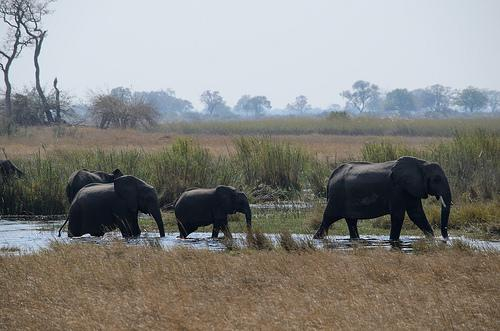Question: how many elephants are there?
Choices:
A. 4.
B. 5.
C. 3.
D. 2.
Answer with the letter. Answer: B Question: what are the elephants doing?
Choices:
A. Sleeping.
B. Drinking.
C. Walking.
D. Bathing.
Answer with the letter. Answer: C Question: what are these animals walking in?
Choices:
A. Mud.
B. Water.
C. Dirt.
D. The jungle.
Answer with the letter. Answer: B Question: what color are the elephant's tusks?
Choices:
A. Brown.
B. White.
C. Black.
D. Red.
Answer with the letter. Answer: B Question: what type of vegetation is mostly seen in the background?
Choices:
A. Bushes.
B. Trees.
C. Shrubs.
D. Flowers.
Answer with the letter. Answer: B 